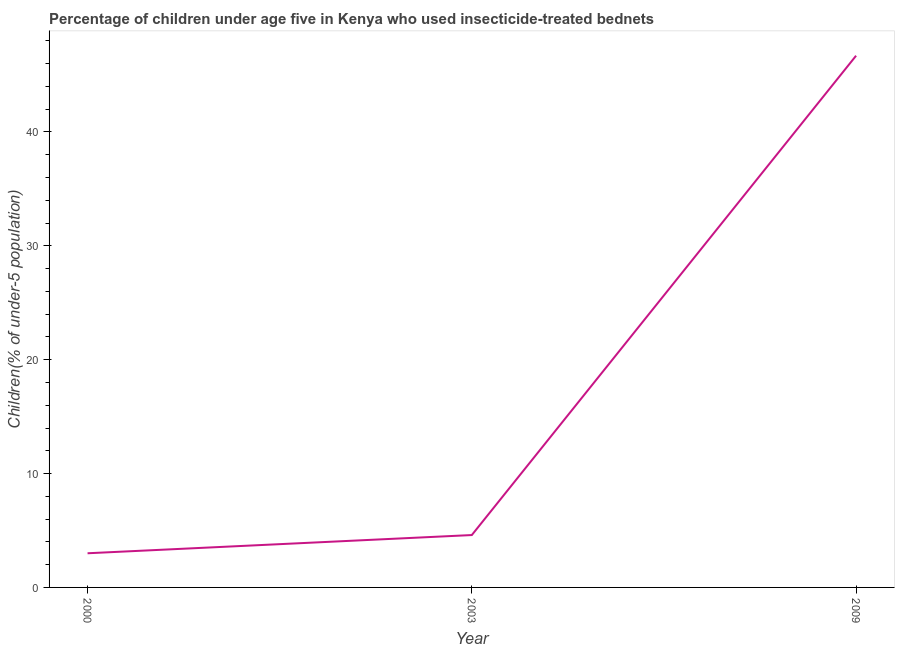Across all years, what is the maximum percentage of children who use of insecticide-treated bed nets?
Make the answer very short. 46.7. In which year was the percentage of children who use of insecticide-treated bed nets minimum?
Provide a succinct answer. 2000. What is the sum of the percentage of children who use of insecticide-treated bed nets?
Your answer should be compact. 54.3. What is the difference between the percentage of children who use of insecticide-treated bed nets in 2000 and 2009?
Make the answer very short. -43.7. Do a majority of the years between 2009 and 2000 (inclusive) have percentage of children who use of insecticide-treated bed nets greater than 12 %?
Ensure brevity in your answer.  No. What is the ratio of the percentage of children who use of insecticide-treated bed nets in 2000 to that in 2003?
Your answer should be very brief. 0.65. Is the difference between the percentage of children who use of insecticide-treated bed nets in 2000 and 2003 greater than the difference between any two years?
Provide a short and direct response. No. What is the difference between the highest and the second highest percentage of children who use of insecticide-treated bed nets?
Offer a very short reply. 42.1. Is the sum of the percentage of children who use of insecticide-treated bed nets in 2000 and 2003 greater than the maximum percentage of children who use of insecticide-treated bed nets across all years?
Provide a succinct answer. No. What is the difference between the highest and the lowest percentage of children who use of insecticide-treated bed nets?
Your answer should be compact. 43.7. In how many years, is the percentage of children who use of insecticide-treated bed nets greater than the average percentage of children who use of insecticide-treated bed nets taken over all years?
Ensure brevity in your answer.  1. Does the percentage of children who use of insecticide-treated bed nets monotonically increase over the years?
Provide a short and direct response. Yes. Are the values on the major ticks of Y-axis written in scientific E-notation?
Make the answer very short. No. What is the title of the graph?
Provide a succinct answer. Percentage of children under age five in Kenya who used insecticide-treated bednets. What is the label or title of the X-axis?
Make the answer very short. Year. What is the label or title of the Y-axis?
Your answer should be compact. Children(% of under-5 population). What is the Children(% of under-5 population) of 2000?
Your response must be concise. 3. What is the Children(% of under-5 population) in 2003?
Your response must be concise. 4.6. What is the Children(% of under-5 population) in 2009?
Your response must be concise. 46.7. What is the difference between the Children(% of under-5 population) in 2000 and 2009?
Give a very brief answer. -43.7. What is the difference between the Children(% of under-5 population) in 2003 and 2009?
Offer a terse response. -42.1. What is the ratio of the Children(% of under-5 population) in 2000 to that in 2003?
Offer a terse response. 0.65. What is the ratio of the Children(% of under-5 population) in 2000 to that in 2009?
Give a very brief answer. 0.06. What is the ratio of the Children(% of under-5 population) in 2003 to that in 2009?
Your answer should be compact. 0.1. 